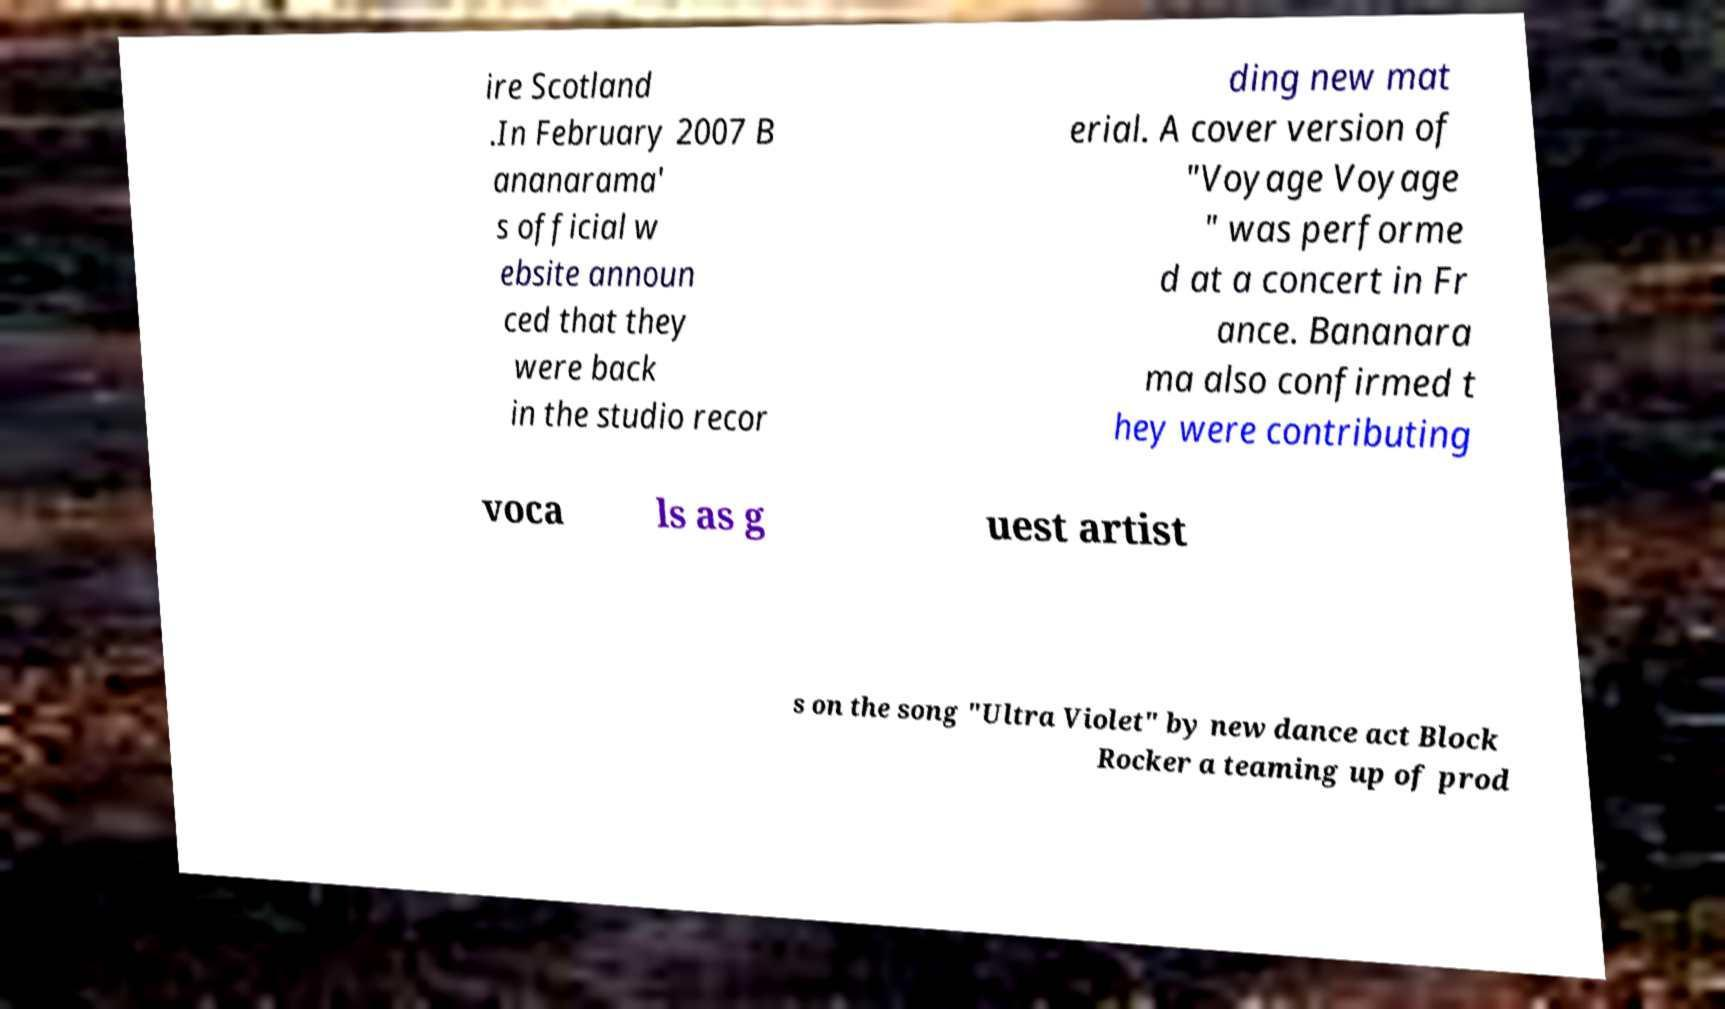Please read and relay the text visible in this image. What does it say? ire Scotland .In February 2007 B ananarama' s official w ebsite announ ced that they were back in the studio recor ding new mat erial. A cover version of "Voyage Voyage " was performe d at a concert in Fr ance. Bananara ma also confirmed t hey were contributing voca ls as g uest artist s on the song "Ultra Violet" by new dance act Block Rocker a teaming up of prod 